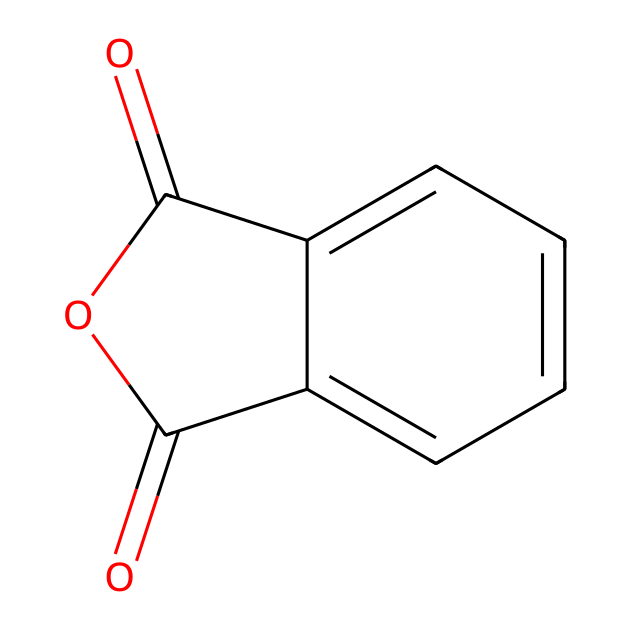What is the name of this chemical? The SMILES representation provided corresponds to phthalic anhydride, which is a common compound in various industrial applications, including fertilizers.
Answer: phthalic anhydride How many carbon atoms are present in the structure? By examining the SMILES, we can count the carbon atoms represented. The "c" and "C" symbols indicate carbon atoms within the rings and attached groups; there are eight in total.
Answer: 8 What type of functional group is present in this compound? In the structure, there are carbonyl (C=O) groups present, which identify the compound as an anhydride. Acid anhydrides are defined by the presence of these functional groups.
Answer: anhydride How many oxygen atoms are there in the structure? The structure shows both carbonyl and the cyclic oxygen in the anhydride part of the molecule. Counting them yields a total of three oxygen atoms.
Answer: 3 What is the molecular formula for phthalic anhydride? To derive the molecular formula, we summarize the count of each atom type found in the structure: C8H4O3 matches the count from the drawing.
Answer: C8H4O3 What is the main application of phthalic anhydride in fertilizers? Phthalic anhydride is predominantly used in the production of plasticizers in fertilizers, which help improve soil structure and nutrient availability.
Answer: plasticizers What type of reaction can phthalic anhydride undergo? As an anhydride, phthalic anhydride can undergo hydrolysis to form phthalic acid when reacted with water. This reaction is characteristic of anhydrides.
Answer: hydrolysis 